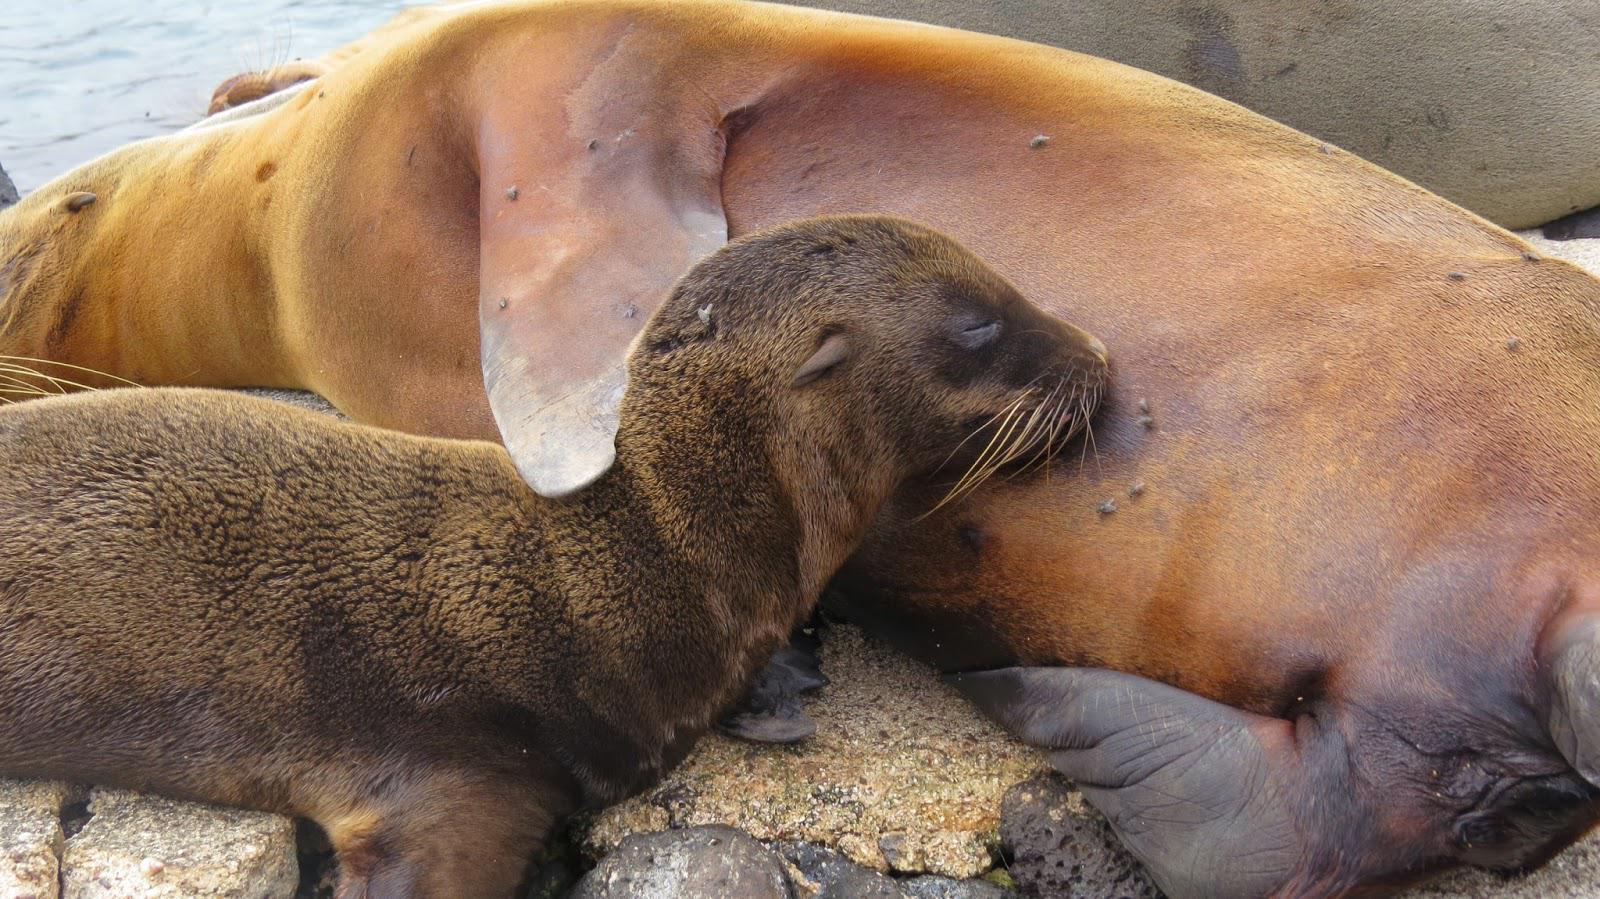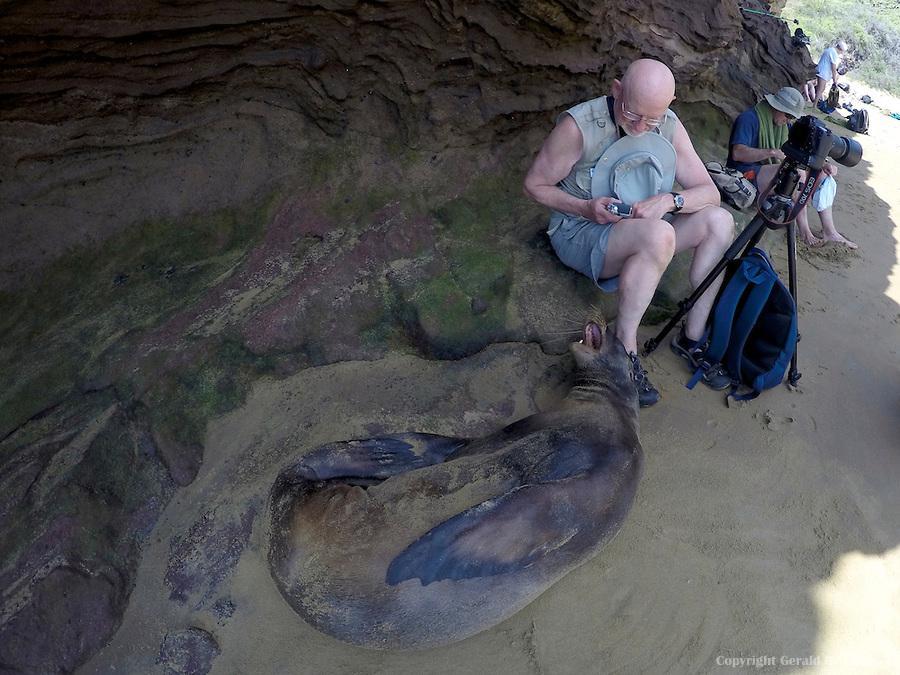The first image is the image on the left, the second image is the image on the right. Analyze the images presented: Is the assertion "Each image includes a dark, wet seal with its head upright, and in at least one image, rocks jut out of the water." valid? Answer yes or no. No. The first image is the image on the left, the second image is the image on the right. Examine the images to the left and right. Is the description "The left image contains no more than one seal." accurate? Answer yes or no. No. 